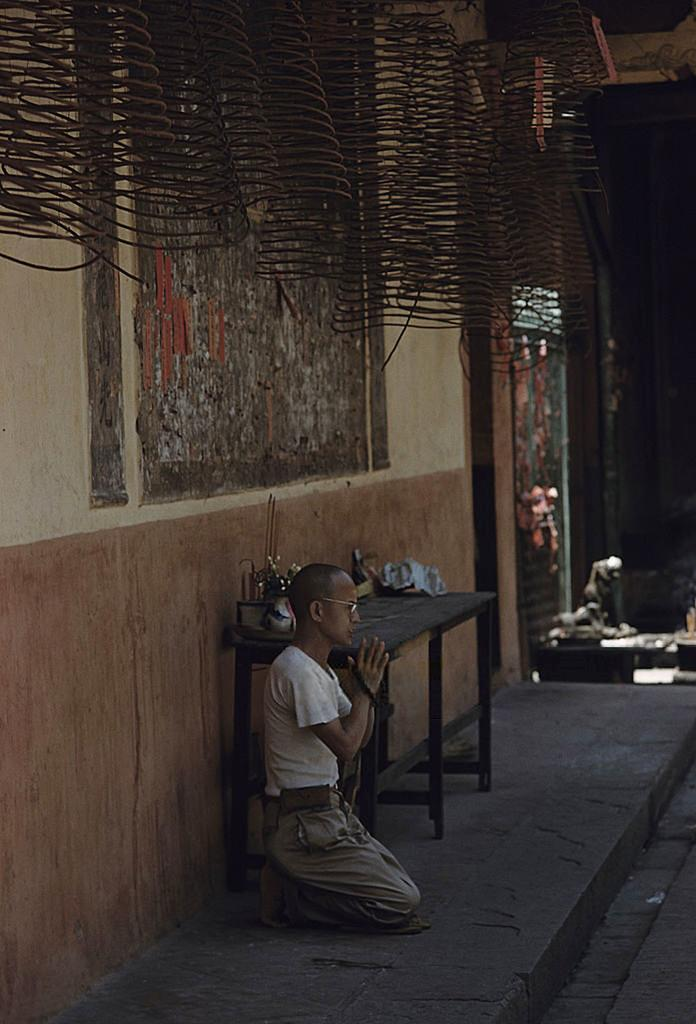What is the person in the image doing? The person is sitting and praying in the image. Where is the person located? The person is on a path. What is present on the path with the person? There is a table in the image. What is on the table? There is a box on the table, as well as other unspecified items and coiled metal objects. What type of pollution can be seen in the image? There is no pollution visible in the image. What kind of marble is present on the table in the image? There is no marble present on the table in the image. 